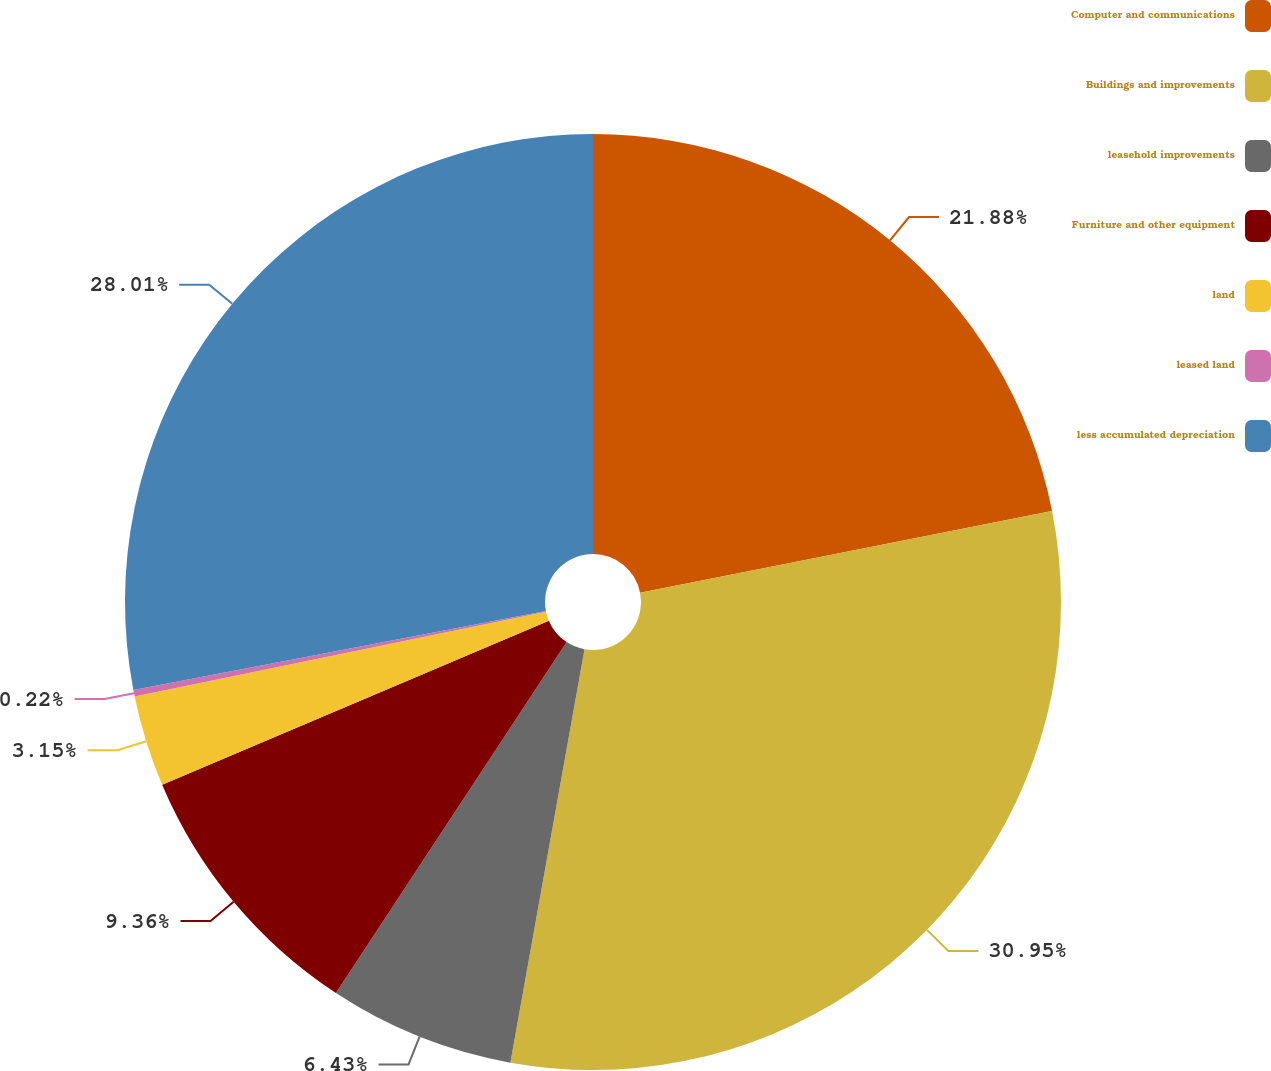<chart> <loc_0><loc_0><loc_500><loc_500><pie_chart><fcel>Computer and communications<fcel>Buildings and improvements<fcel>leasehold improvements<fcel>Furniture and other equipment<fcel>land<fcel>leased land<fcel>less accumulated depreciation<nl><fcel>21.88%<fcel>30.94%<fcel>6.43%<fcel>9.36%<fcel>3.15%<fcel>0.22%<fcel>28.01%<nl></chart> 